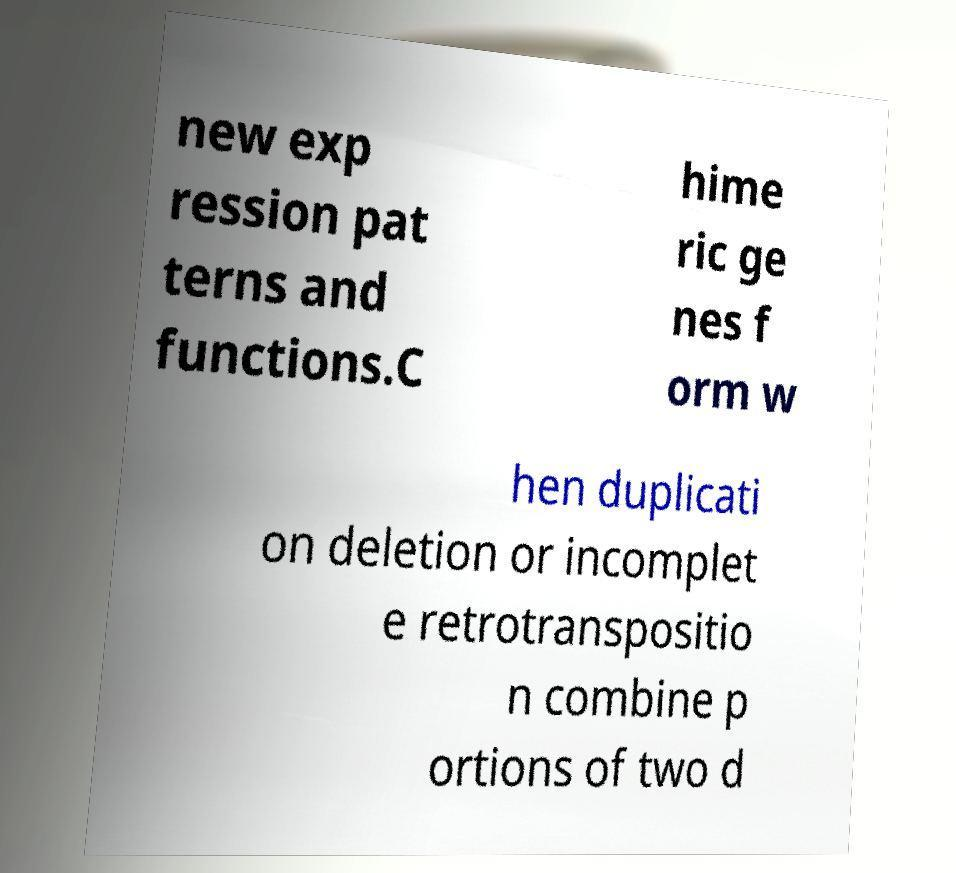Could you extract and type out the text from this image? new exp ression pat terns and functions.C hime ric ge nes f orm w hen duplicati on deletion or incomplet e retrotranspositio n combine p ortions of two d 